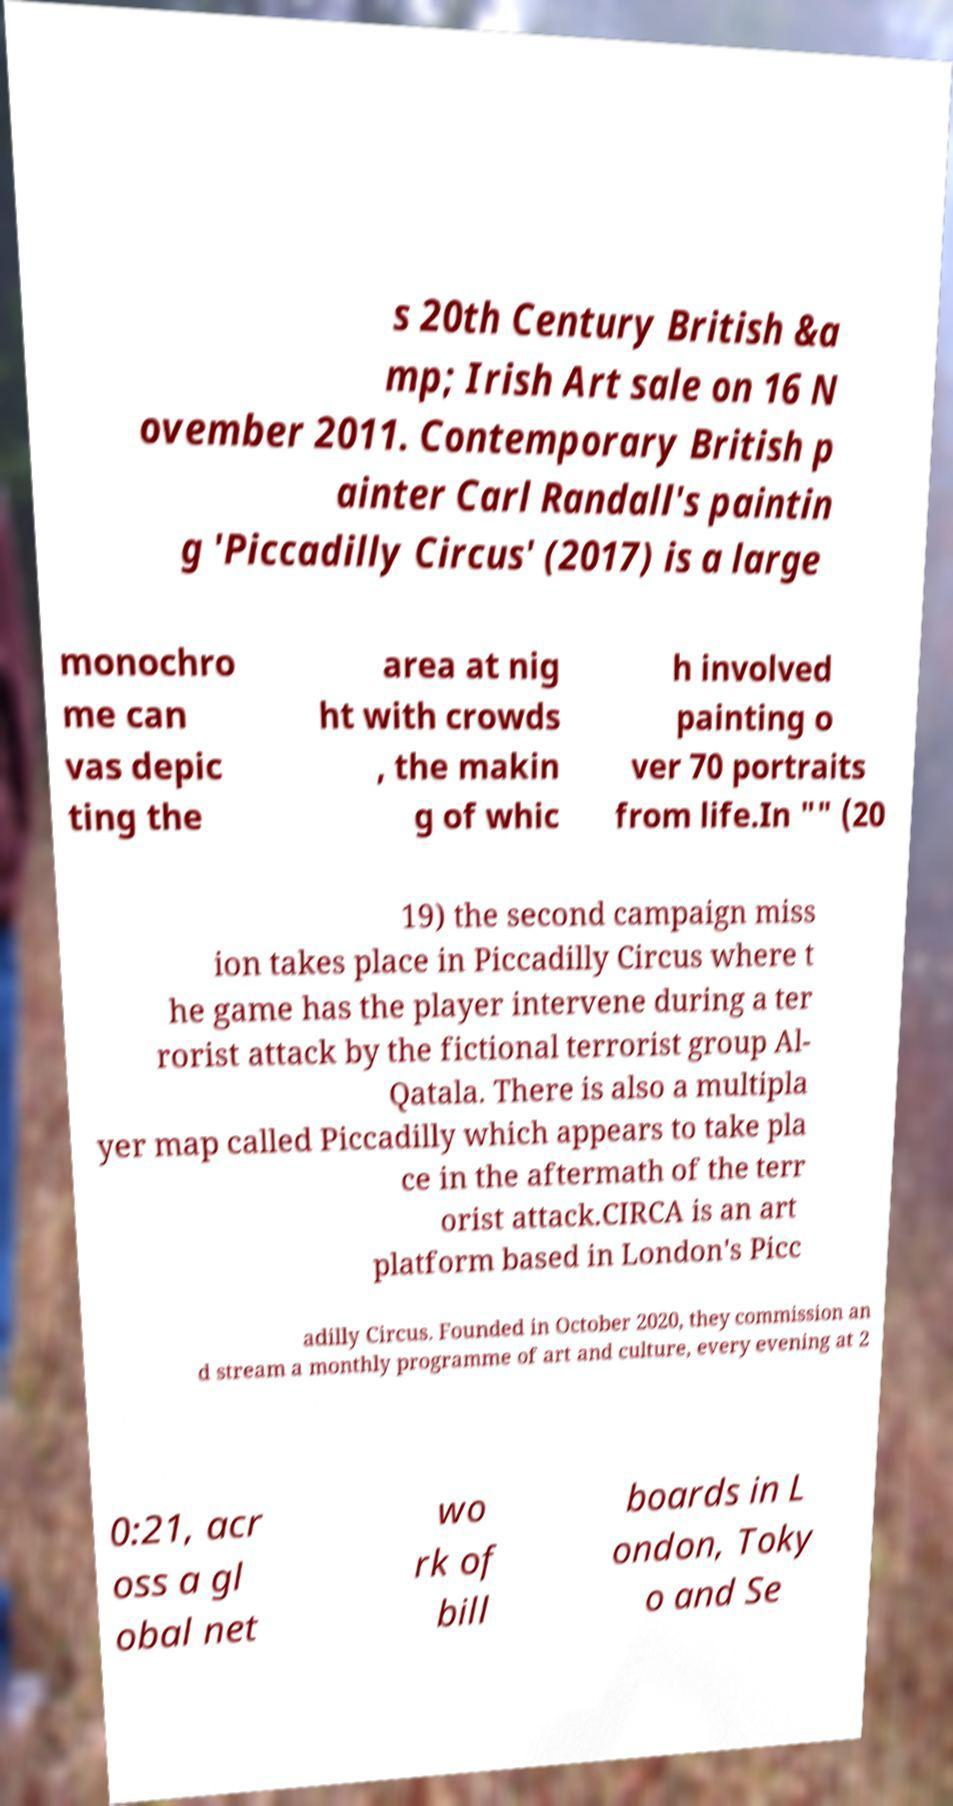Could you assist in decoding the text presented in this image and type it out clearly? s 20th Century British &a mp; Irish Art sale on 16 N ovember 2011. Contemporary British p ainter Carl Randall's paintin g 'Piccadilly Circus' (2017) is a large monochro me can vas depic ting the area at nig ht with crowds , the makin g of whic h involved painting o ver 70 portraits from life.In "" (20 19) the second campaign miss ion takes place in Piccadilly Circus where t he game has the player intervene during a ter rorist attack by the fictional terrorist group Al- Qatala. There is also a multipla yer map called Piccadilly which appears to take pla ce in the aftermath of the terr orist attack.CIRCA is an art platform based in London's Picc adilly Circus. Founded in October 2020, they commission an d stream a monthly programme of art and culture, every evening at 2 0:21, acr oss a gl obal net wo rk of bill boards in L ondon, Toky o and Se 